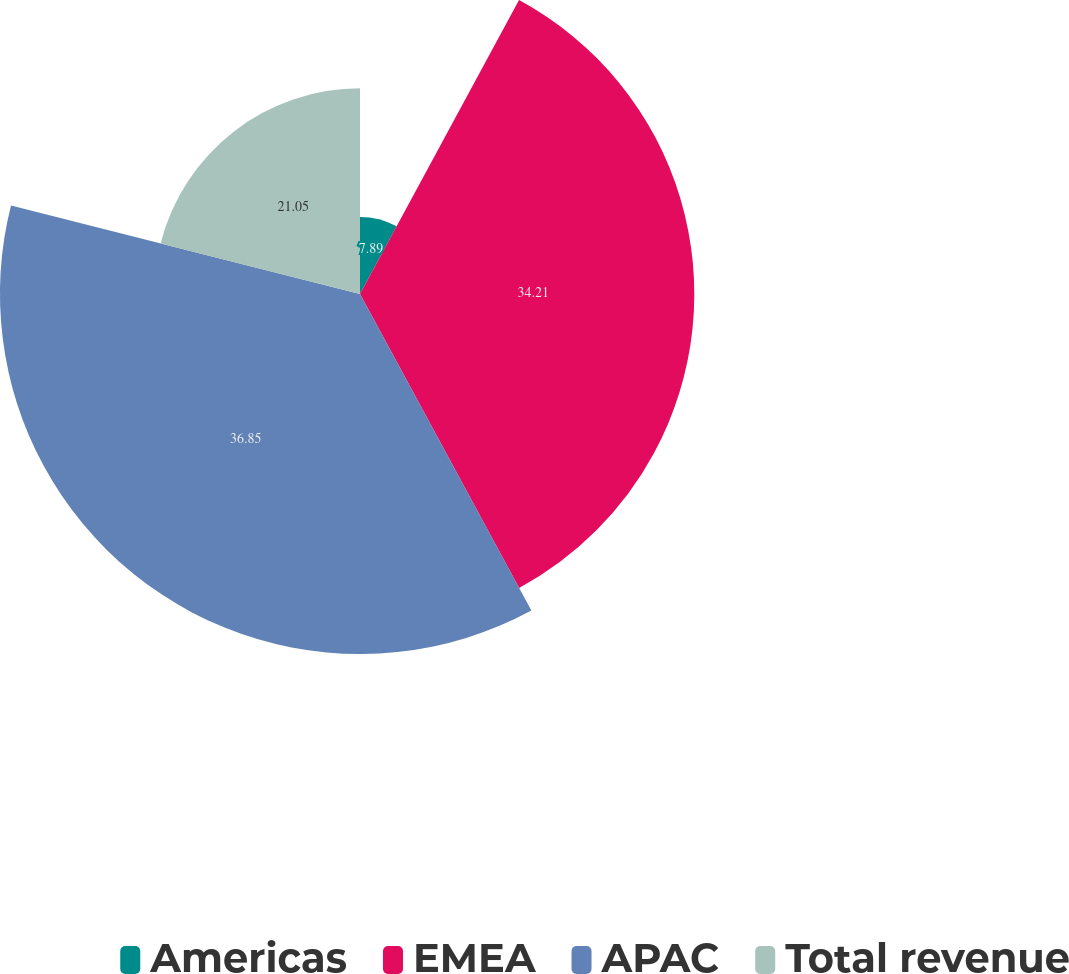Convert chart to OTSL. <chart><loc_0><loc_0><loc_500><loc_500><pie_chart><fcel>Americas<fcel>EMEA<fcel>APAC<fcel>Total revenue<nl><fcel>7.89%<fcel>34.21%<fcel>36.84%<fcel>21.05%<nl></chart> 